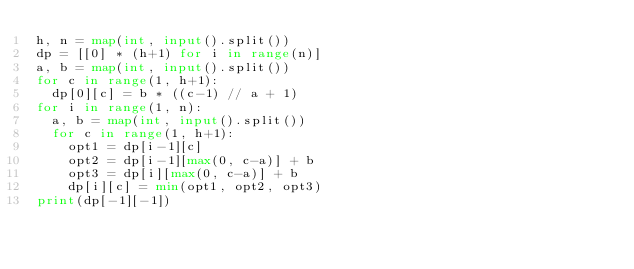<code> <loc_0><loc_0><loc_500><loc_500><_Python_>h, n = map(int, input().split())
dp = [[0] * (h+1) for i in range(n)]
a, b = map(int, input().split())
for c in range(1, h+1):
  dp[0][c] = b * ((c-1) // a + 1)
for i in range(1, n):
  a, b = map(int, input().split())
  for c in range(1, h+1):
    opt1 = dp[i-1][c]
    opt2 = dp[i-1][max(0, c-a)] + b
    opt3 = dp[i][max(0, c-a)] + b
    dp[i][c] = min(opt1, opt2, opt3)
print(dp[-1][-1])</code> 